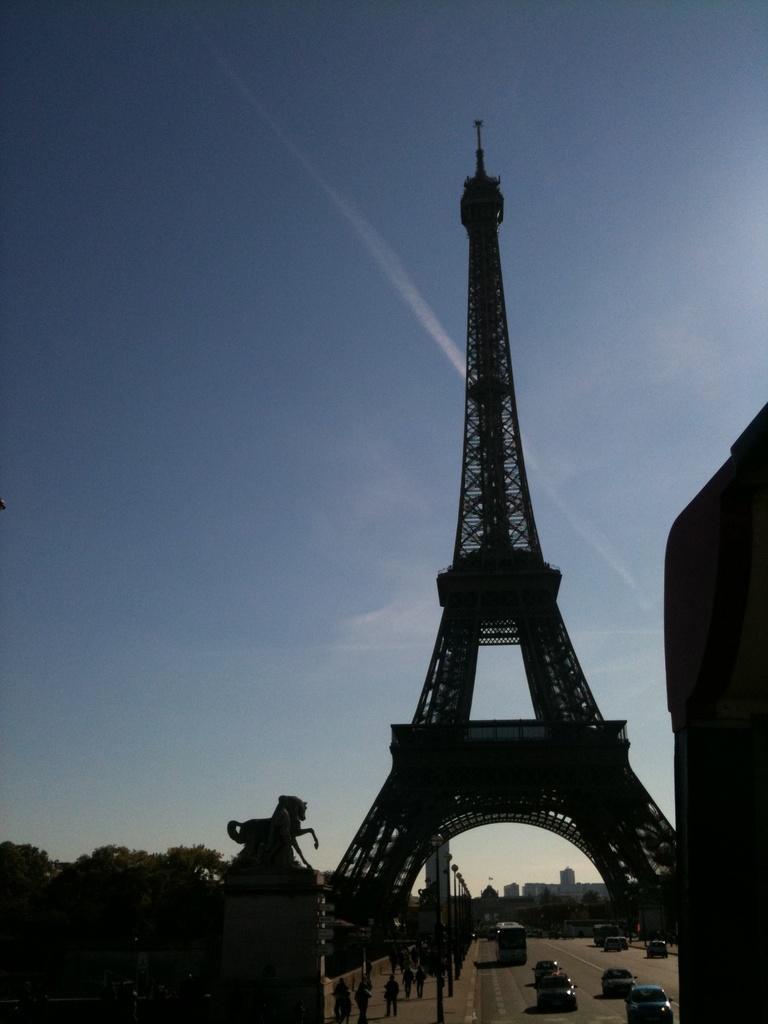Please provide a concise description of this image. In the image there is a tall tower, around the tower there are trees and buildings and under the tower there are vehicles on the road and on the left side of the road few people are on the footpath. 